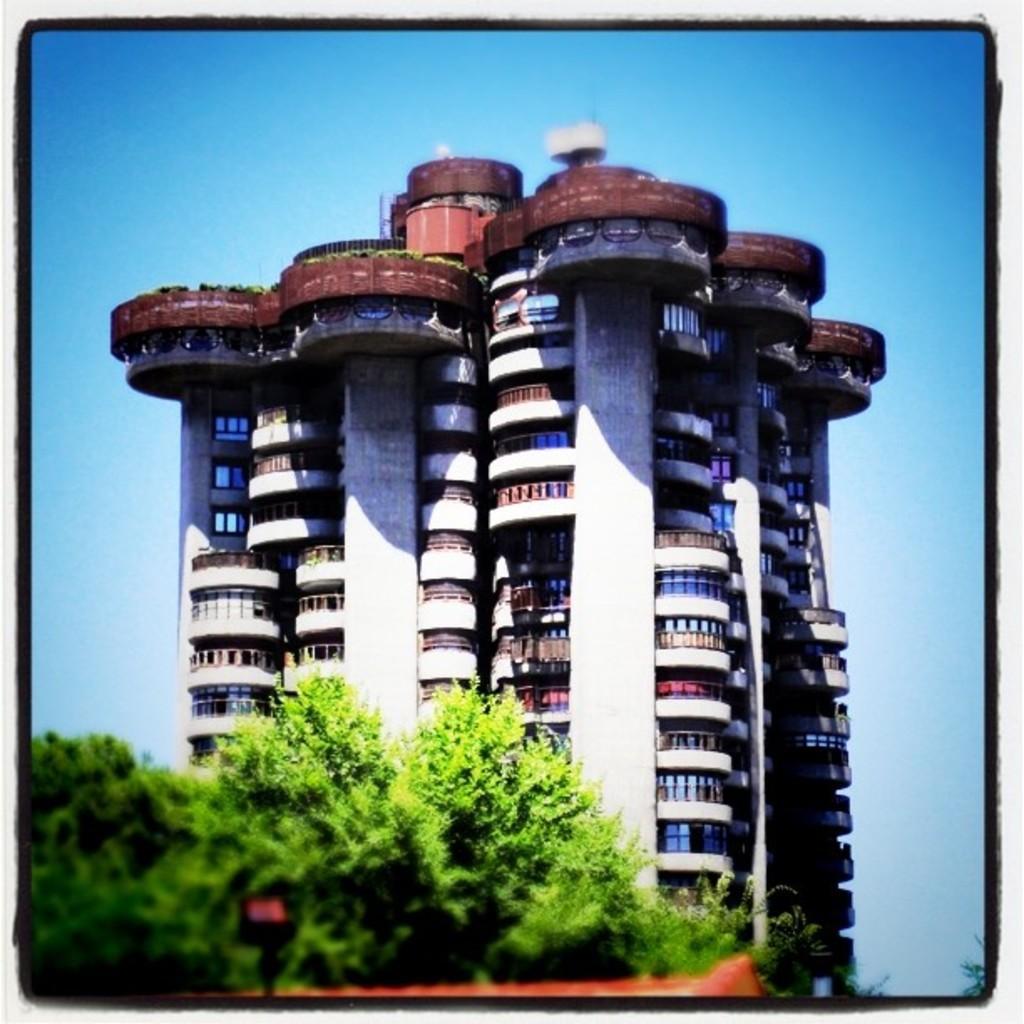In one or two sentences, can you explain what this image depicts? In this image there is a huge building, in front of the building there are trees. In the background there is a sky. 